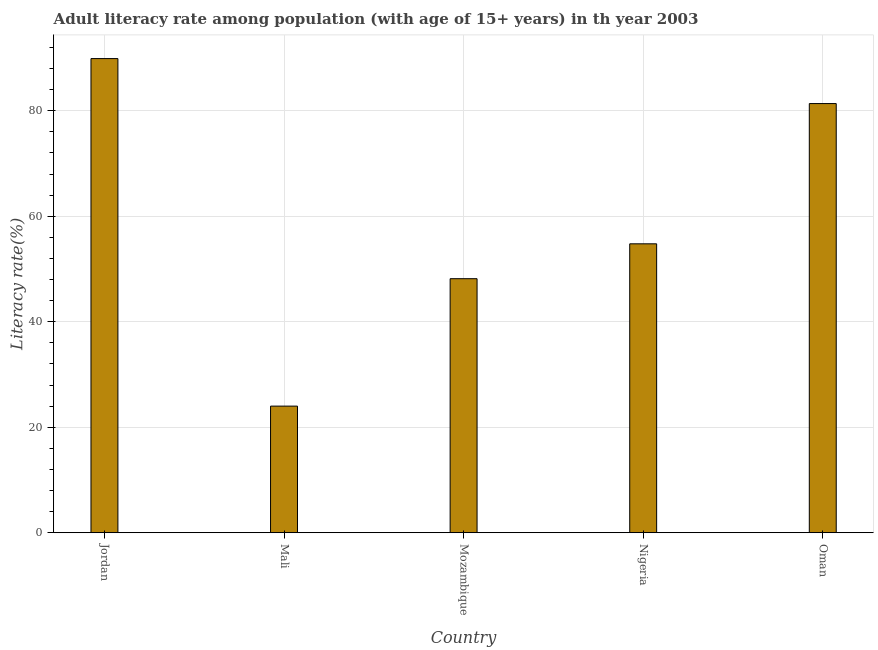What is the title of the graph?
Offer a terse response. Adult literacy rate among population (with age of 15+ years) in th year 2003. What is the label or title of the X-axis?
Give a very brief answer. Country. What is the label or title of the Y-axis?
Offer a terse response. Literacy rate(%). What is the adult literacy rate in Oman?
Provide a short and direct response. 81.36. Across all countries, what is the maximum adult literacy rate?
Make the answer very short. 89.89. Across all countries, what is the minimum adult literacy rate?
Provide a short and direct response. 24. In which country was the adult literacy rate maximum?
Give a very brief answer. Jordan. In which country was the adult literacy rate minimum?
Give a very brief answer. Mali. What is the sum of the adult literacy rate?
Give a very brief answer. 298.19. What is the difference between the adult literacy rate in Jordan and Nigeria?
Your answer should be compact. 35.12. What is the average adult literacy rate per country?
Your answer should be very brief. 59.64. What is the median adult literacy rate?
Your answer should be compact. 54.77. In how many countries, is the adult literacy rate greater than 28 %?
Your answer should be compact. 4. What is the ratio of the adult literacy rate in Jordan to that in Oman?
Your answer should be compact. 1.1. Is the adult literacy rate in Mozambique less than that in Oman?
Make the answer very short. Yes. What is the difference between the highest and the second highest adult literacy rate?
Ensure brevity in your answer.  8.53. What is the difference between the highest and the lowest adult literacy rate?
Keep it short and to the point. 65.89. In how many countries, is the adult literacy rate greater than the average adult literacy rate taken over all countries?
Make the answer very short. 2. How many bars are there?
Provide a succinct answer. 5. Are all the bars in the graph horizontal?
Your answer should be compact. No. Are the values on the major ticks of Y-axis written in scientific E-notation?
Your response must be concise. No. What is the Literacy rate(%) in Jordan?
Your answer should be compact. 89.89. What is the Literacy rate(%) of Mali?
Make the answer very short. 24. What is the Literacy rate(%) of Mozambique?
Your answer should be compact. 48.16. What is the Literacy rate(%) in Nigeria?
Provide a succinct answer. 54.77. What is the Literacy rate(%) in Oman?
Offer a terse response. 81.36. What is the difference between the Literacy rate(%) in Jordan and Mali?
Your answer should be compact. 65.89. What is the difference between the Literacy rate(%) in Jordan and Mozambique?
Provide a short and direct response. 41.73. What is the difference between the Literacy rate(%) in Jordan and Nigeria?
Ensure brevity in your answer.  35.12. What is the difference between the Literacy rate(%) in Jordan and Oman?
Make the answer very short. 8.53. What is the difference between the Literacy rate(%) in Mali and Mozambique?
Give a very brief answer. -24.16. What is the difference between the Literacy rate(%) in Mali and Nigeria?
Provide a succinct answer. -30.77. What is the difference between the Literacy rate(%) in Mali and Oman?
Provide a succinct answer. -57.36. What is the difference between the Literacy rate(%) in Mozambique and Nigeria?
Keep it short and to the point. -6.61. What is the difference between the Literacy rate(%) in Mozambique and Oman?
Your response must be concise. -33.2. What is the difference between the Literacy rate(%) in Nigeria and Oman?
Offer a very short reply. -26.59. What is the ratio of the Literacy rate(%) in Jordan to that in Mali?
Your response must be concise. 3.75. What is the ratio of the Literacy rate(%) in Jordan to that in Mozambique?
Your response must be concise. 1.87. What is the ratio of the Literacy rate(%) in Jordan to that in Nigeria?
Your response must be concise. 1.64. What is the ratio of the Literacy rate(%) in Jordan to that in Oman?
Your answer should be very brief. 1.1. What is the ratio of the Literacy rate(%) in Mali to that in Mozambique?
Offer a very short reply. 0.5. What is the ratio of the Literacy rate(%) in Mali to that in Nigeria?
Provide a succinct answer. 0.44. What is the ratio of the Literacy rate(%) in Mali to that in Oman?
Offer a terse response. 0.29. What is the ratio of the Literacy rate(%) in Mozambique to that in Nigeria?
Offer a terse response. 0.88. What is the ratio of the Literacy rate(%) in Mozambique to that in Oman?
Your response must be concise. 0.59. What is the ratio of the Literacy rate(%) in Nigeria to that in Oman?
Your response must be concise. 0.67. 